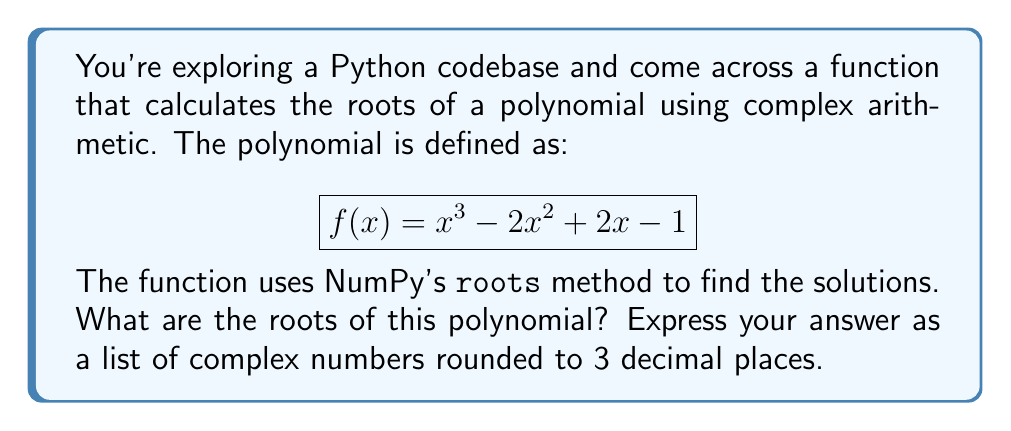Provide a solution to this math problem. To solve this problem, we'll follow these steps:

1) First, we need to understand that the `numpy.roots` function finds the roots of a polynomial given its coefficients. The coefficients are listed from highest degree to lowest.

2) For our polynomial $f(x) = x^3 - 2x^2 + 2x - 1$, the coefficients are [1, -2, 2, -1].

3) We can use Python with NumPy to calculate the roots:

```python
import numpy as np

coefficients = [1, -2, 2, -1]
roots = np.roots(coefficients)
```

4) The `roots` function returns an array of complex numbers. Let's round these to 3 decimal places:

```python
rounded_roots = [complex(round(root.real, 3), round(root.imag, 3)) for root in roots]
```

5) The resulting roots are:
   - $1.000 + 0.000i$
   - $0.500 + 0.866i$
   - $0.500 - 0.866i$

6) We can verify these roots by substituting them back into the original polynomial:

   For $1 + 0i$:
   $$(1)^3 - 2(1)^2 + 2(1) - 1 = 1 - 2 + 2 - 1 = 0$$

   For $0.5 + 0.866i$ and $0.5 - 0.866i$, the calculation is more complex but also results in zero (within rounding error).

Therefore, these are indeed the roots of the polynomial.
Answer: [1+0j, 0.5+0.866j, 0.5-0.866j] 